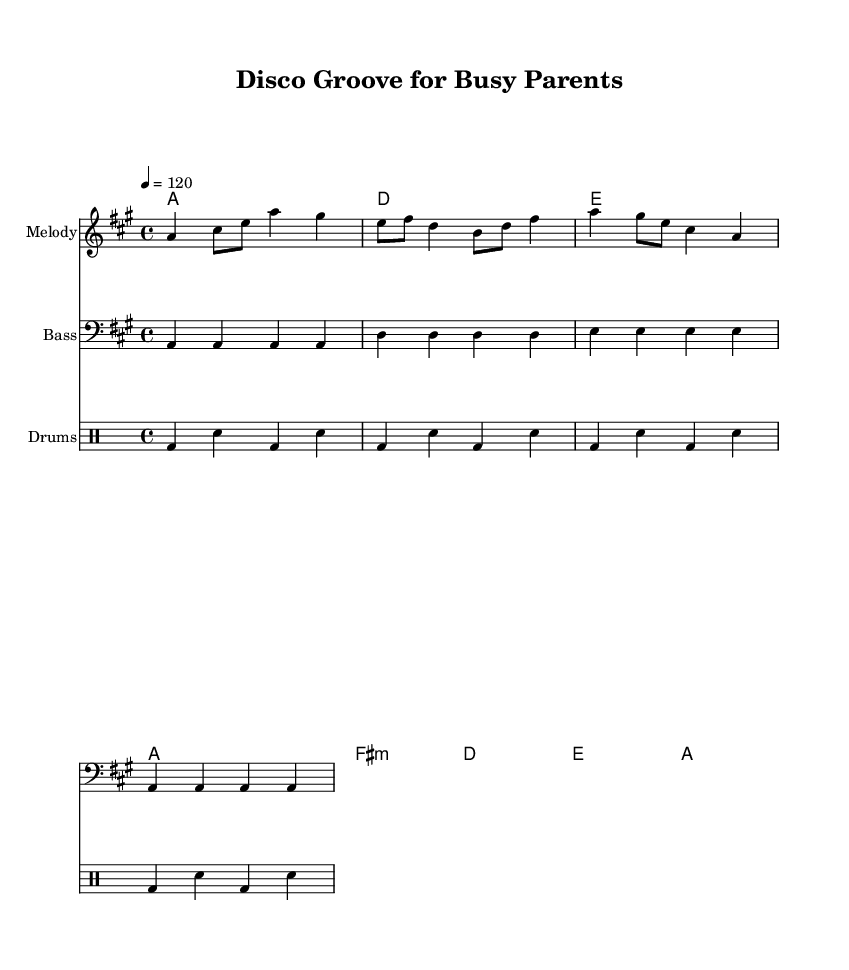What is the key signature of this music? The key signature shown is A major, which has three sharps (F#, C#, and G#). This can be identified from the sharp symbols at the beginning of the staff.
Answer: A major What is the time signature of this piece? The time signature is indicated as 4/4, meaning there are four beats in each measure and a quarter note receives one beat. This is denoted at the start of the music.
Answer: 4/4 What is the tempo marking for this piece? The tempo marking indicates a speed of 120 beats per minute (bpm), which is specified at the beginning of the score as "4 = 120".
Answer: 120 How many measures are in the melody section? Counting each group of notes separated by vertical lines (bar lines), there are four distinct measures in the melody section of the score.
Answer: 4 What is the last chord in the harmony section? The last chord shown is an A major chord, which can be determined by identifying the final chord symbol in the harmony section.
Answer: A What instrument is indicated for the bass part? The bass part is labeled with "Bass" in the title above the staff, indicating it is for a bass instrument.
Answer: Bass What type of rhythm pattern is predominant in the drums? The predominant rhythm pattern in the drums consists of a bass drum followed by a snare drum in a repetitive structure throughout the score. This can be recognized by the consistent alternating placement of the notes in the drummode section.
Answer: Bass-snare 